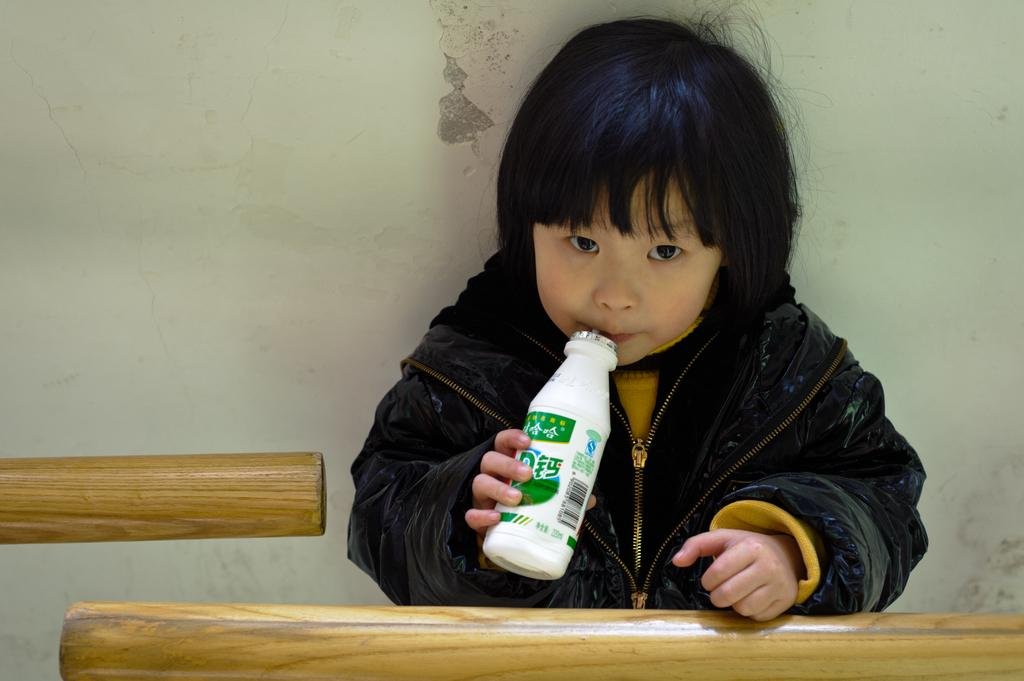What is the main subject of the image? There is a child in the image. What is the child holding in the image? The child is holding a bottle. What type of order does the child place at the restaurant in the image? There is no restaurant or order present in the image; it only features a child holding a bottle. 